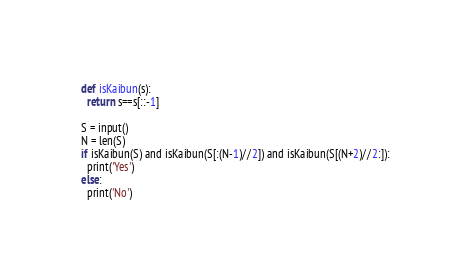<code> <loc_0><loc_0><loc_500><loc_500><_Python_>def isKaibun(s):
  return s==s[::-1]

S = input()
N = len(S)
if isKaibun(S) and isKaibun(S[:(N-1)//2]) and isKaibun(S[(N+2)//2:]):
  print('Yes')
else:
  print('No')</code> 